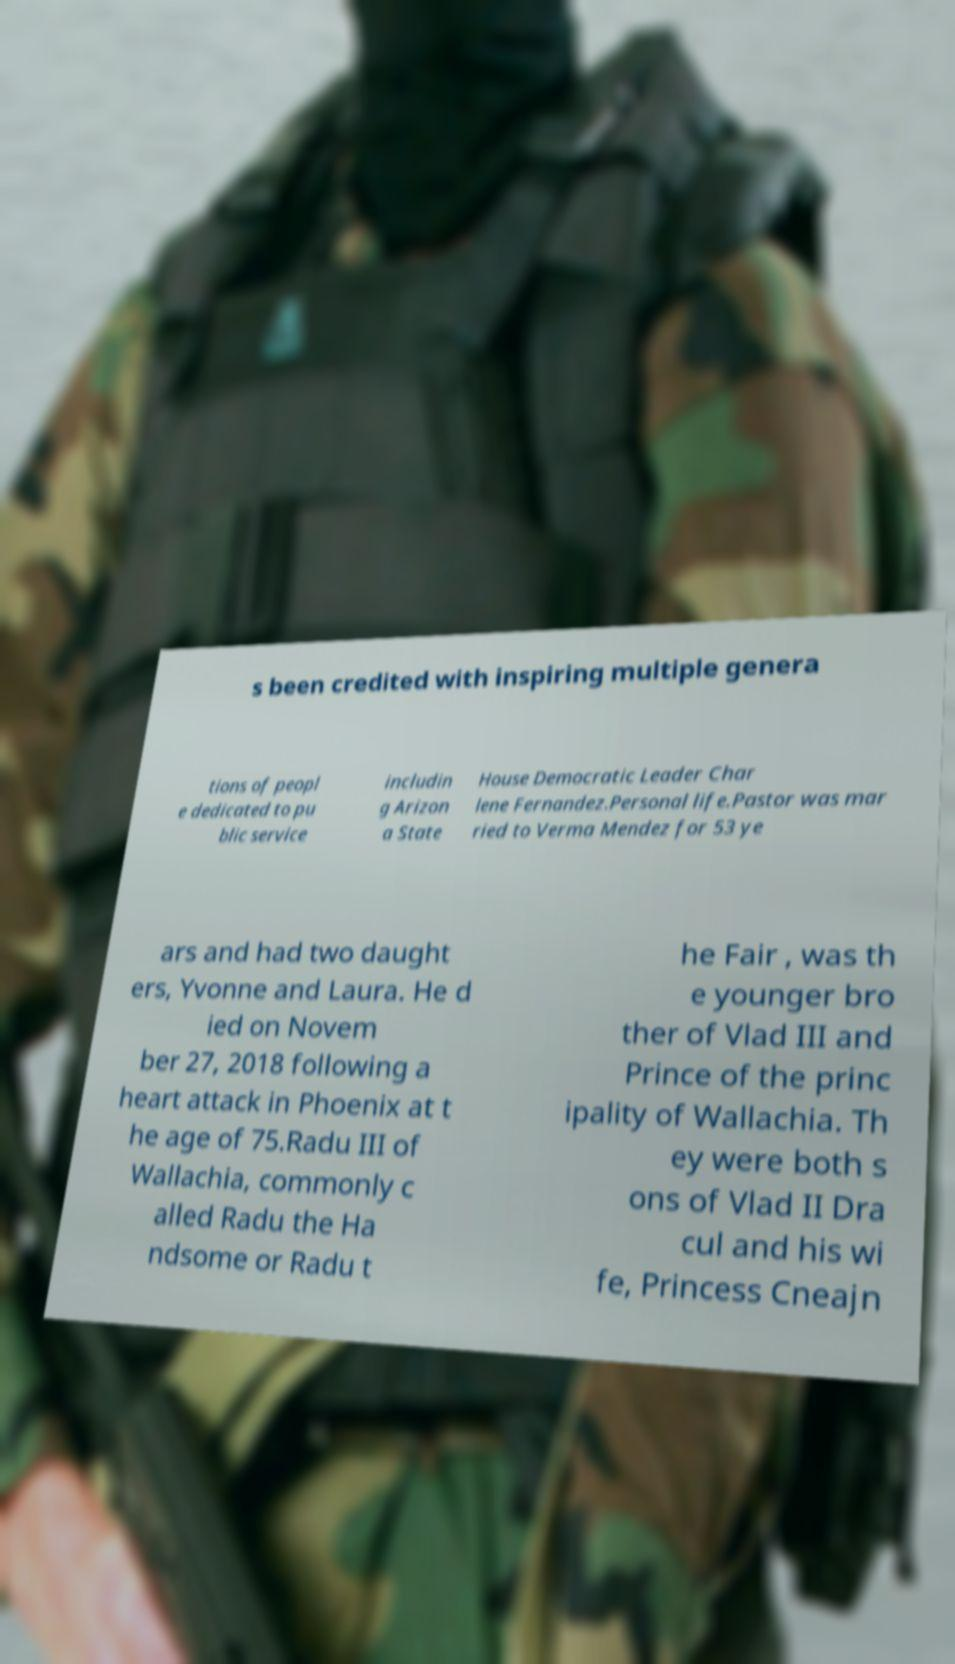Could you assist in decoding the text presented in this image and type it out clearly? s been credited with inspiring multiple genera tions of peopl e dedicated to pu blic service includin g Arizon a State House Democratic Leader Char lene Fernandez.Personal life.Pastor was mar ried to Verma Mendez for 53 ye ars and had two daught ers, Yvonne and Laura. He d ied on Novem ber 27, 2018 following a heart attack in Phoenix at t he age of 75.Radu III of Wallachia, commonly c alled Radu the Ha ndsome or Radu t he Fair , was th e younger bro ther of Vlad III and Prince of the princ ipality of Wallachia. Th ey were both s ons of Vlad II Dra cul and his wi fe, Princess Cneajn 